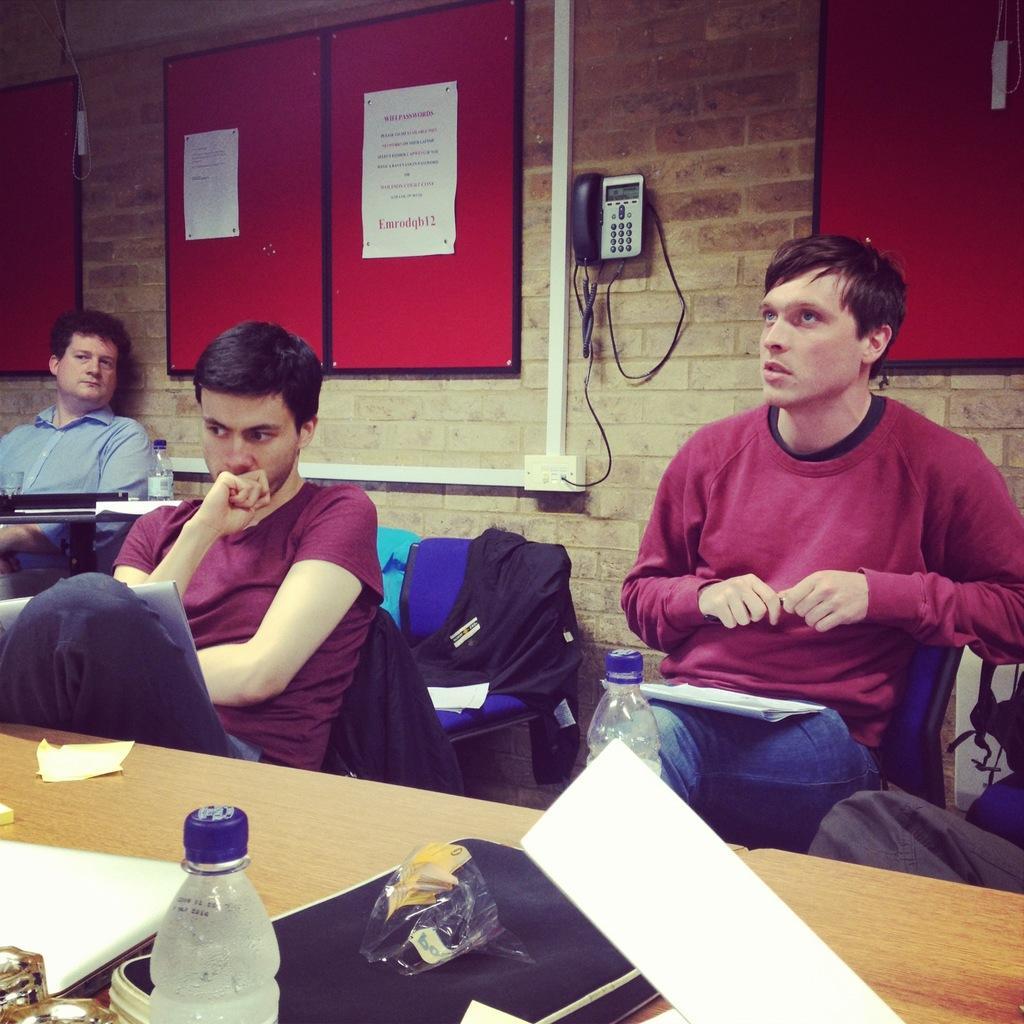Could you give a brief overview of what you see in this image? In this picture we can see three men sitting on chairs and in front of them on table we have files, bottles, bag, plastic covers and in background we can see wall with telephone, poles, board with stickers to it. 